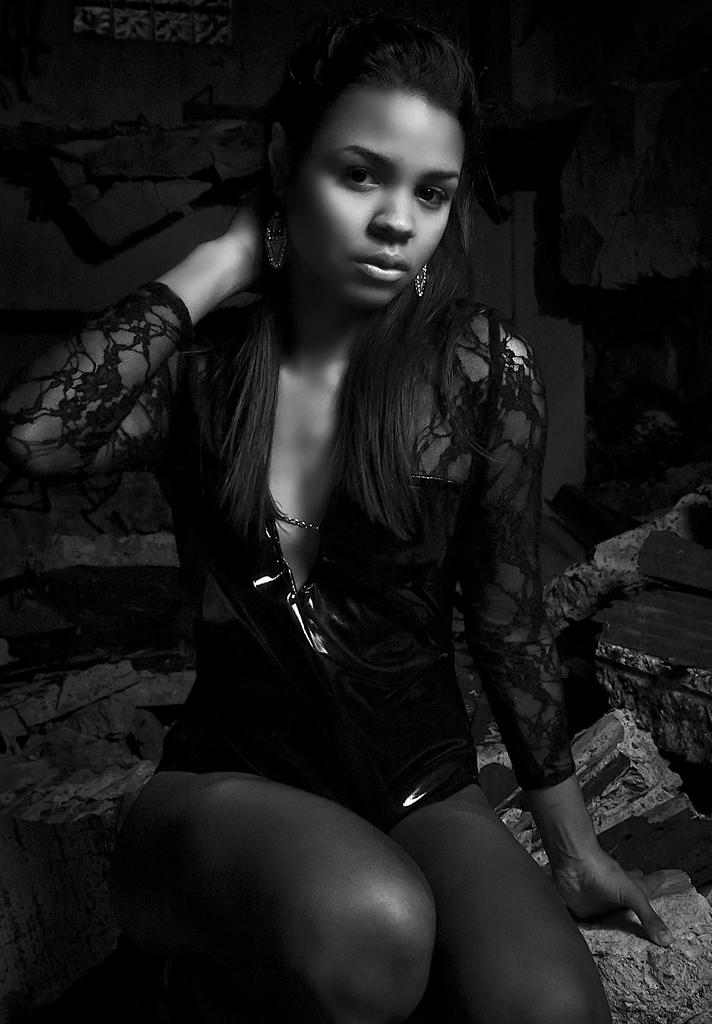Who is the main subject in the image? There is a woman in the image. What is the woman doing in the image? The woman is sitting on a bed. What is the woman wearing in the image? The woman is wearing a black color transparent shirt. What is the woman doing with her hand in the image? The woman has her hand on her neck. How would you describe the lighting or color of the background in the image? The background of the image appears dark. What type of liquid can be seen dripping from the top of the woman's head in the image? There is no liquid dripping from the top of the woman's head in the image. 